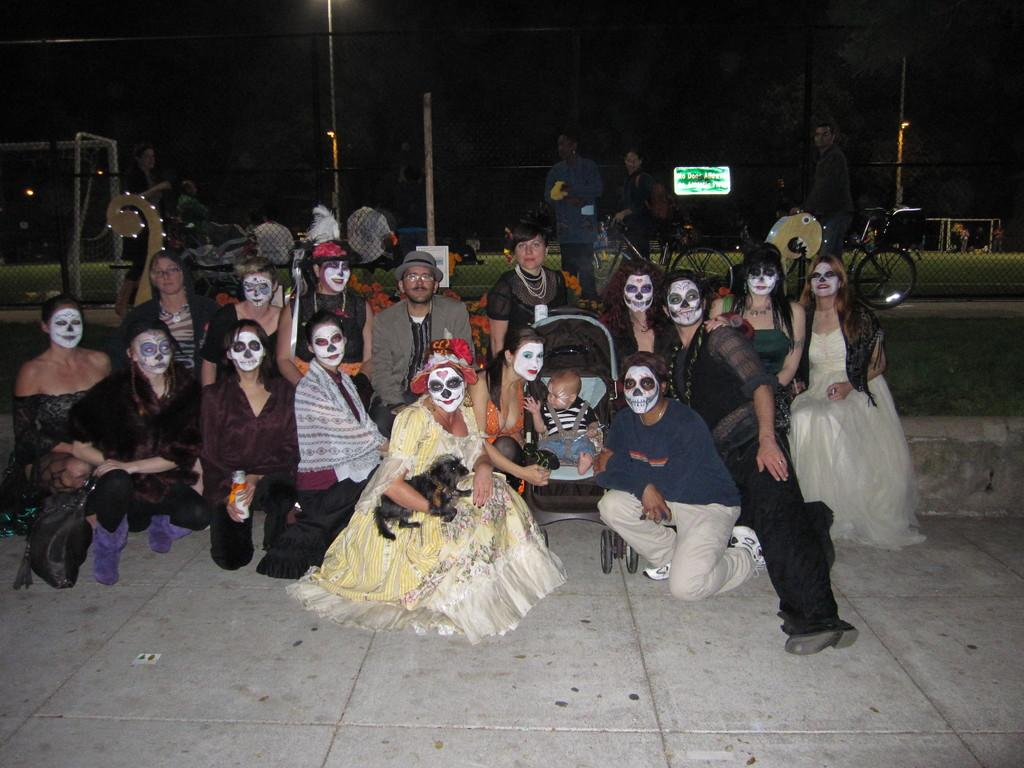What is a common characteristic among some of the persons in the image? Some of the persons in the image have white color paint on their faces. Are there any other persons in the image who do not have painted faces? Yes, there are other persons sitting among those with painted faces. What can be seen in the background of the image? There is a fence and trees in the background of the image. What type of cake is being served to the cats in the image? There are no cats or cake present in the image. 